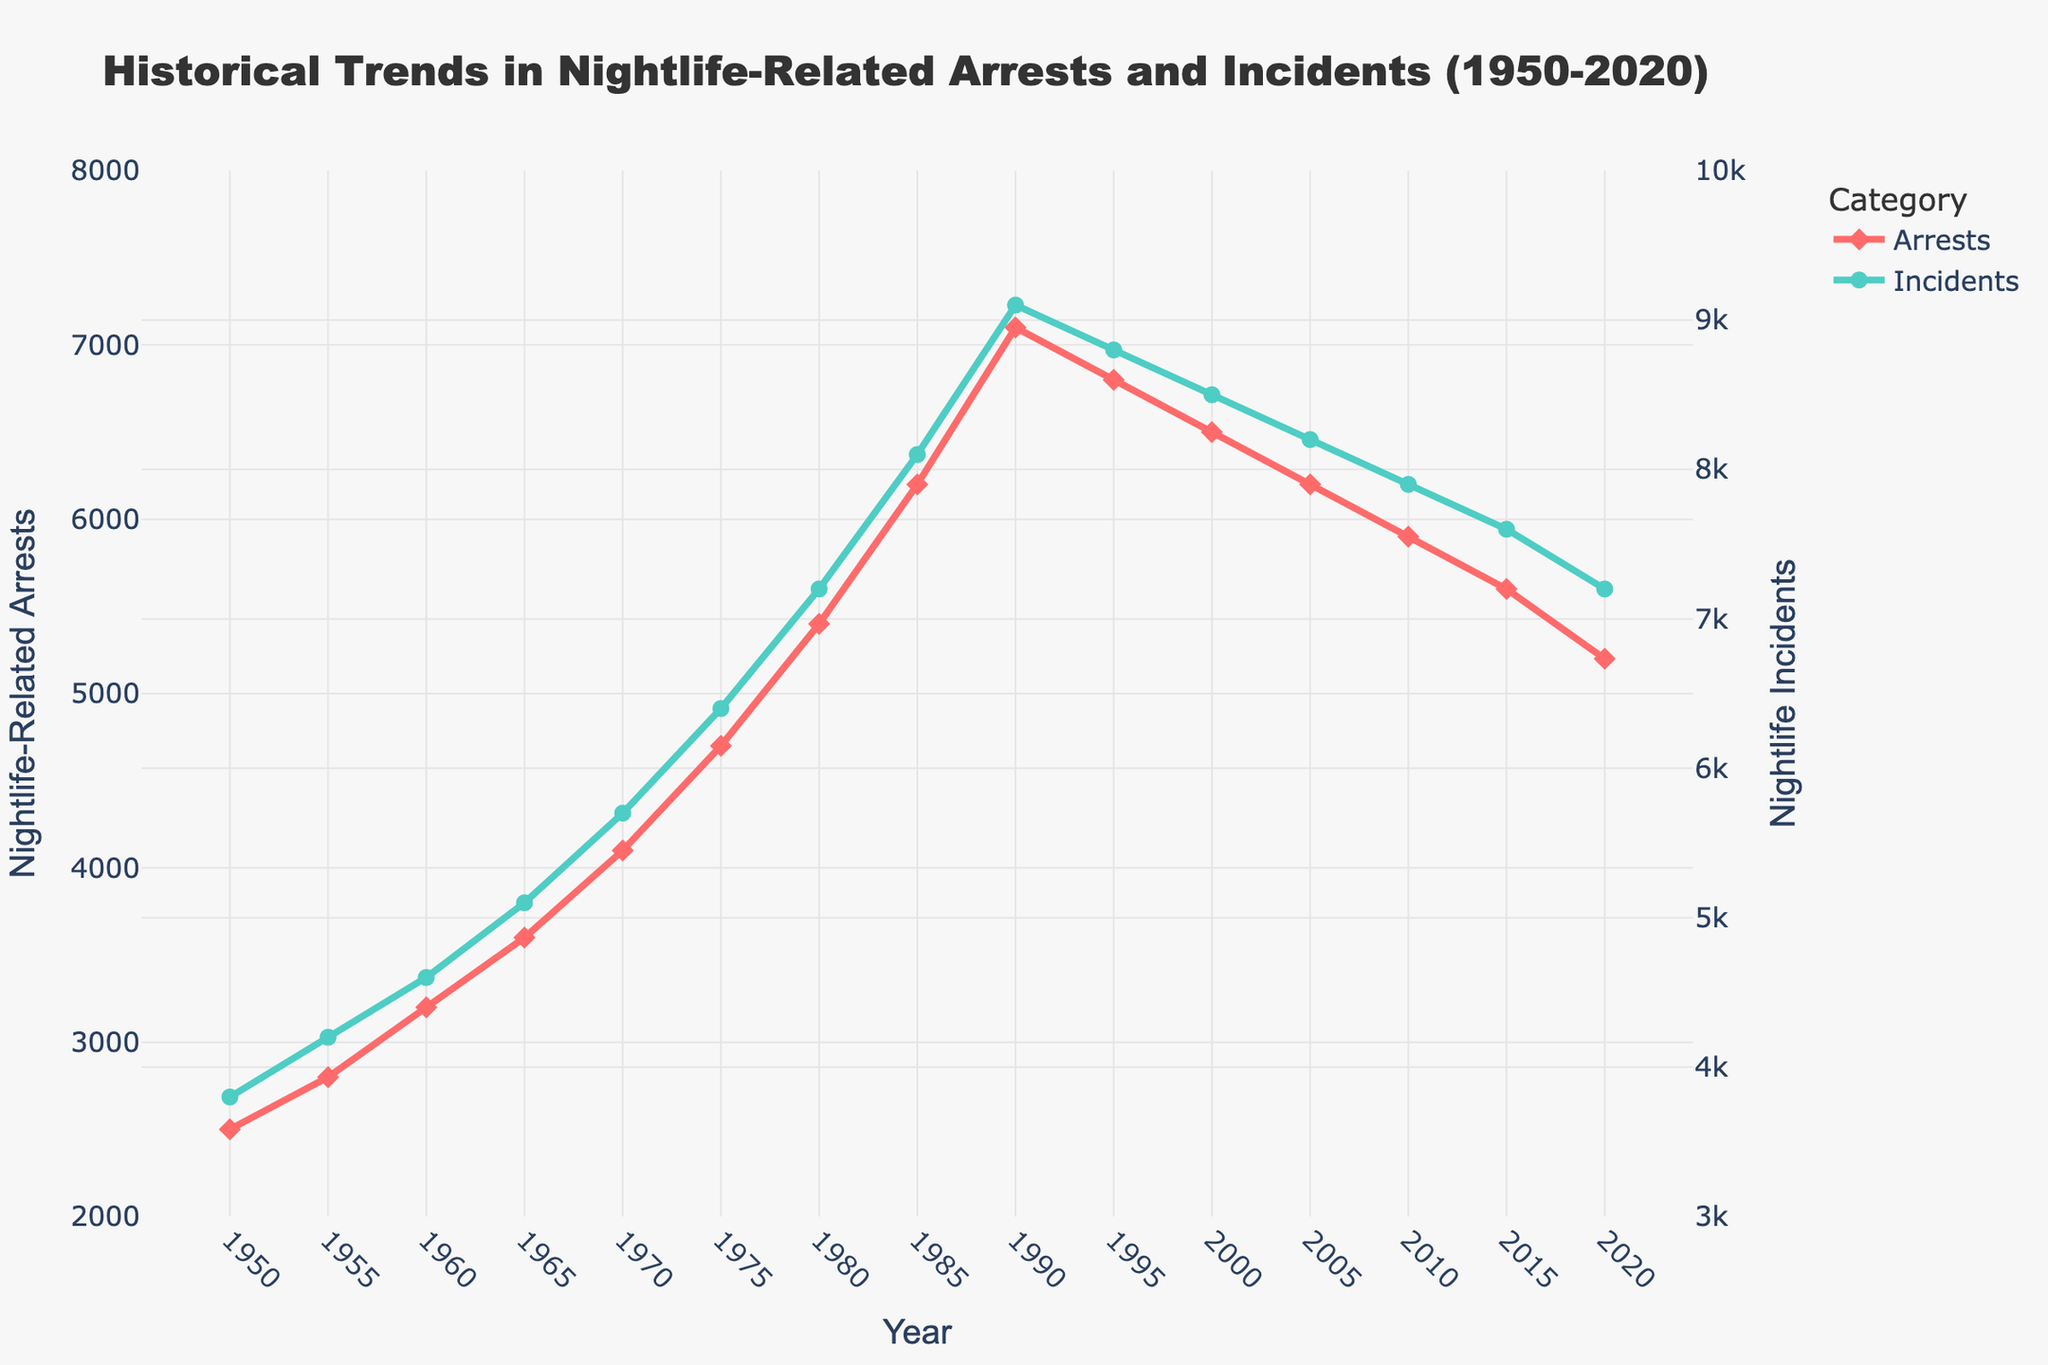What is the trend of nightlife-related arrests from 1950 to 2020? The trend in nightlife-related arrests has generally increased from 1950 to a peak in 1990 and then gradually declined up to 2020.
Answer: Increased until 1990, then declined Which year had the highest number of nightlife incidents? The highest number of nightlife incidents can be seen at the peak point around 1990, which tallies with around 9100 incidents.
Answer: 1990 In which decade did nightlife-related arrests stop increasing and begin to decline? By observing the plot, the nightlife-related arrests peaked in 1990 and then began to decline, indicating the transition from the 1980s to the 1990s decade.
Answer: 1990s What were the counts of nightlife-related arrests and incidents in 1970? By looking at the year 1970 on the x-axis and reading the corresponding y-values, the number of nightlife-related arrests is around 4100 and nightlife incidents is around 5700.
Answer: 4100 arrests and 5700 incidents How did the number of nightlife incidents change from 1960 to 2010? From 1960 to 2010, the number of nightlife incidents increased from 4600 to a peak of 9100 in the 1990s, then declined steadily to around 7900 by 2010.
Answer: Rose, peaked, then declined Compare the number of nightlife-related arrests in 1985 and 2005. The number of nightlife-related arrests in 1985 is 6200, while in 2005 it is 6200. Comparing these values shows a slight reduction by 2005.
Answer: Decreased What is the visual difference between the trend lines for arrests and incidents? The trend lines for arrests and incidents generally follow the same pattern, although the incidents trend line is consistently higher. The incidents line is green with circular markers, while the arrests line is red with diamond markers.
Answer: Incidents higher, different colors and markers During which period did nightlife incidents and arrests move in opposite directions? Between 1990 and 2020, arrests declined from 7100 to 5200, while incidents saw an initial drop, a brief increase, then a decline, mostly moving in the same direction.
Answer: Not observed often 